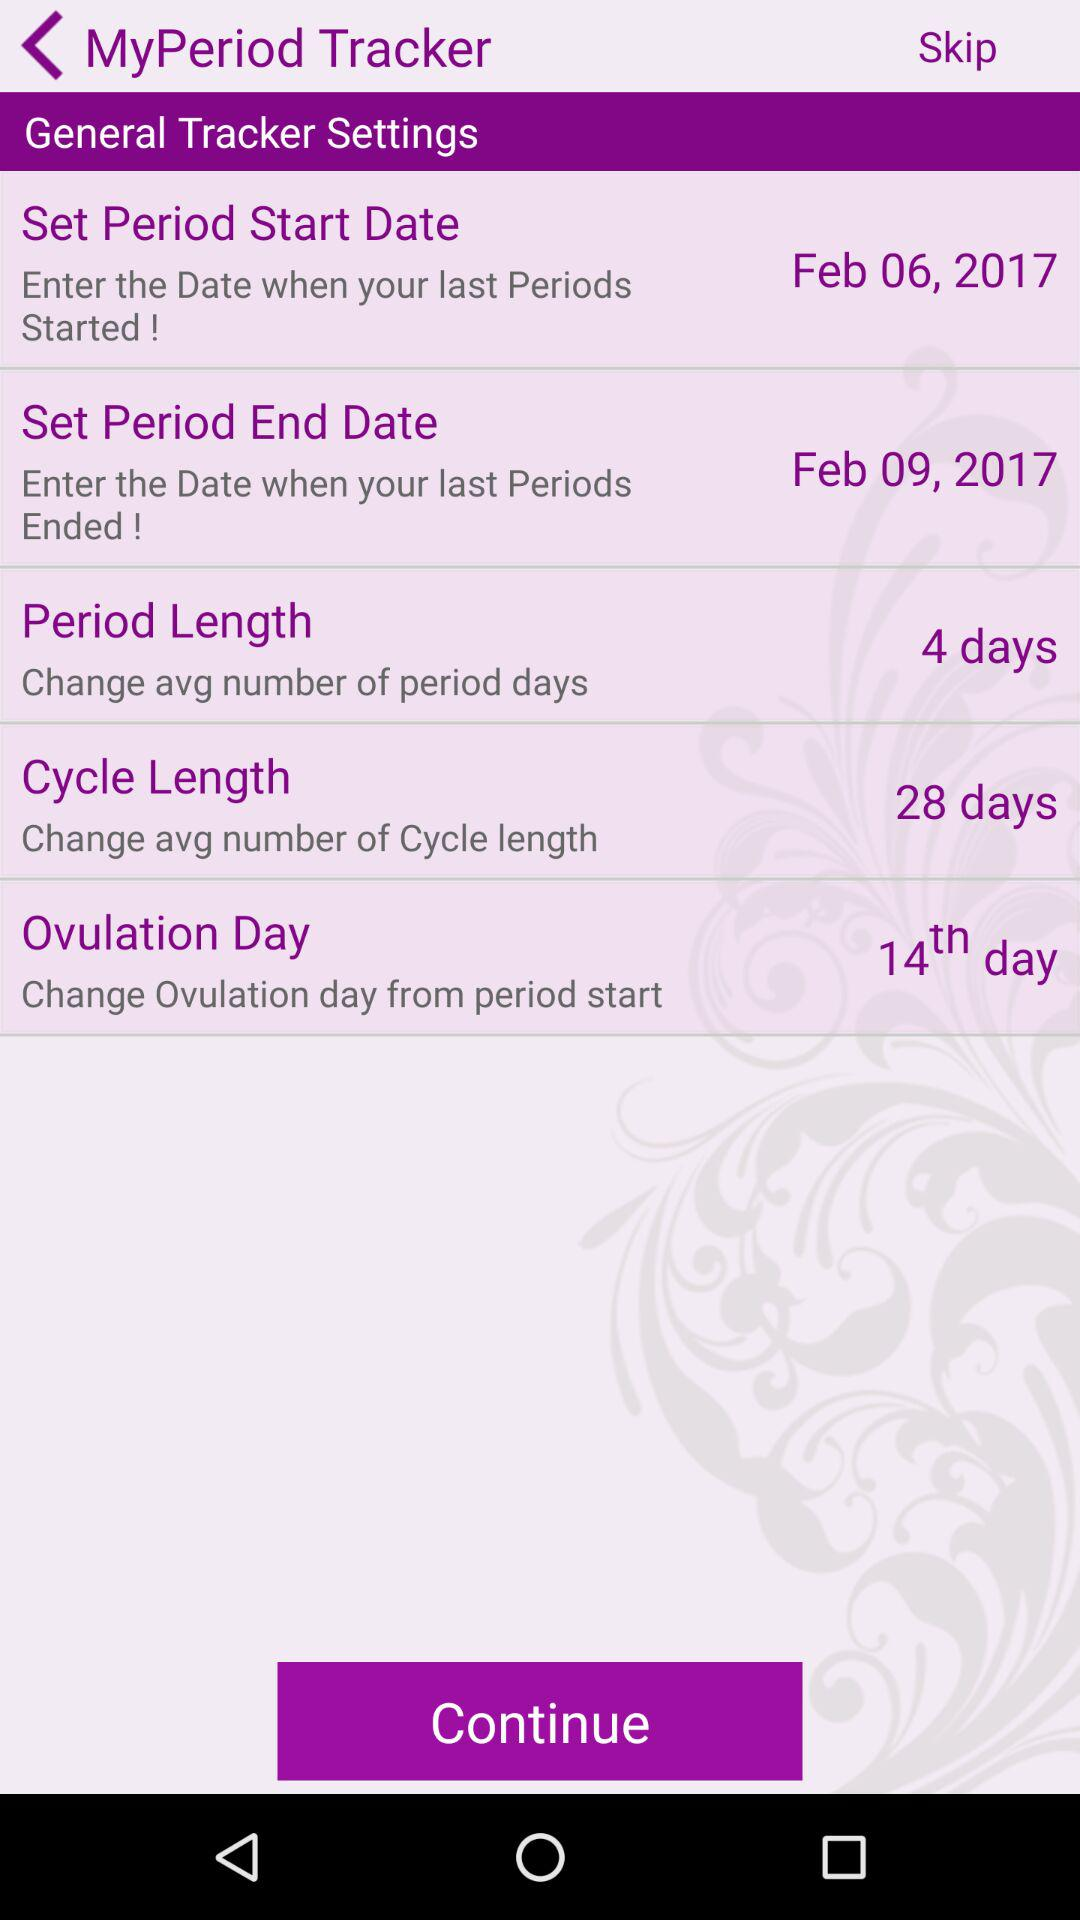For which setting is "14th day" the selected option? "14th day" is the selected option for the "Ovulation Day" setting. 